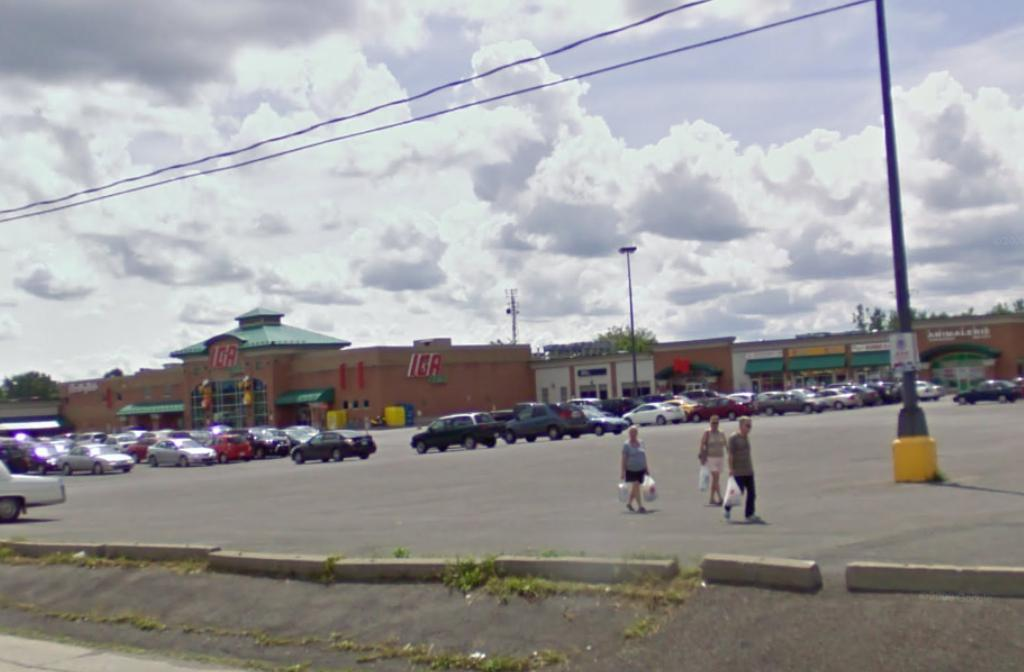<image>
Summarize the visual content of the image. Three people carrying bags near an ICA supermarket behind them. 